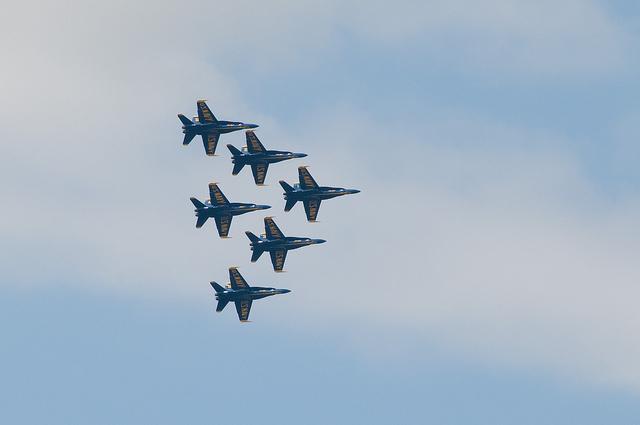What number is on the middle plane?
Answer briefly. 1. What type of plane is this?
Quick response, please. Jet. How many planes are there?
Quick response, please. 6. What color is the plane?
Give a very brief answer. Blue. How many planes?
Be succinct. 6. How many planes are in the air?
Keep it brief. 6. Is it storming?
Be succinct. No. Are these all the same type of plane?
Write a very short answer. Yes. How many planes are in the image?
Give a very brief answer. 6. Is this a military plane?
Give a very brief answer. Yes. How many jets are there?
Be succinct. 6. Is there any vapor trails?
Short answer required. No. How many planets are in the sky?
Be succinct. 6. What is the predominant color of the planes?
Answer briefly. Blue. Are the planes too close to one another?
Be succinct. No. Where is the smoke coming from?
Quick response, please. Planes. What is unusual about this photo?
Give a very brief answer. Nothing. What color are the planes?
Short answer required. Blue. What is the name of this squadron?
Keep it brief. Blue angels. 